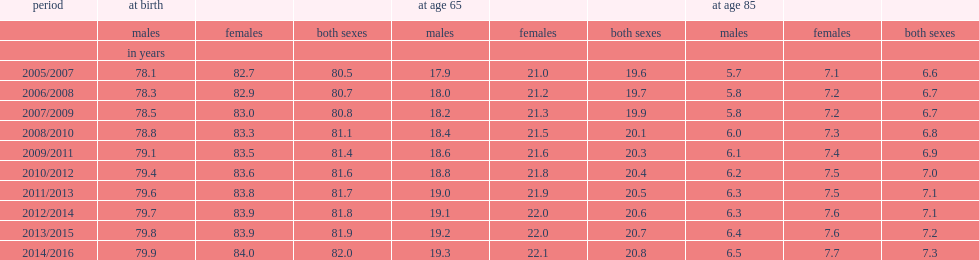In which year does life expectancy reach a peak in canada for both sexes? 2014/2016. How many years does life expectancy at birth reach for both sexes in 2014/2016 in canada? 82.0. How many years does life expectancy at birth reach for women in 2014/2016? 84.0. How many years does life expectancy at birth reach for men in 2014/2016? 79.9. How many years does life expectancy at birth increase by for females in 2014/2016 compared to the values recorded for the period 2013/2015? 0.1. How many years does life expectancy at birth increase by for males in 2014/2016 compared to the values recorded for the period 2013/2015? 0.1. 